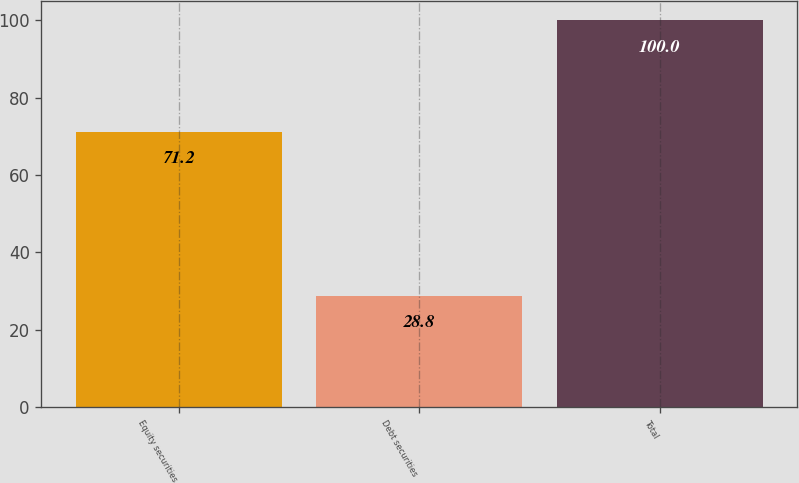<chart> <loc_0><loc_0><loc_500><loc_500><bar_chart><fcel>Equity securities<fcel>Debt securities<fcel>Total<nl><fcel>71.2<fcel>28.8<fcel>100<nl></chart> 